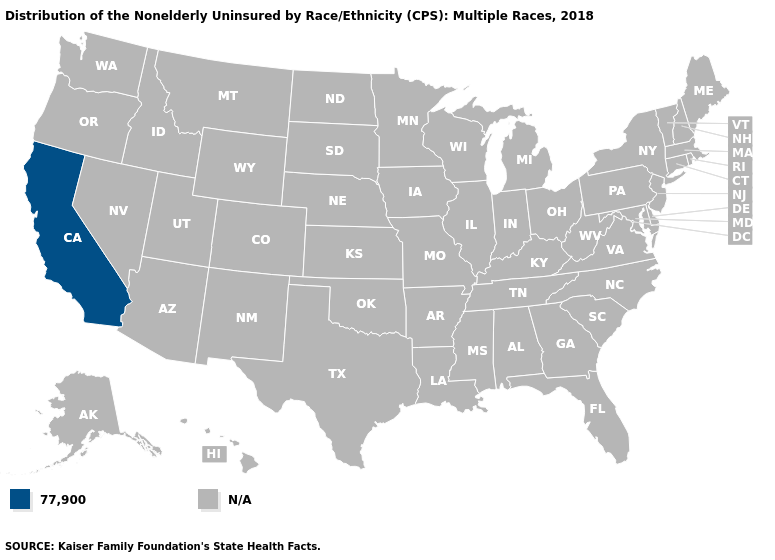What is the highest value in the USA?
Answer briefly. 77,900. Name the states that have a value in the range N/A?
Answer briefly. Alabama, Alaska, Arizona, Arkansas, Colorado, Connecticut, Delaware, Florida, Georgia, Hawaii, Idaho, Illinois, Indiana, Iowa, Kansas, Kentucky, Louisiana, Maine, Maryland, Massachusetts, Michigan, Minnesota, Mississippi, Missouri, Montana, Nebraska, Nevada, New Hampshire, New Jersey, New Mexico, New York, North Carolina, North Dakota, Ohio, Oklahoma, Oregon, Pennsylvania, Rhode Island, South Carolina, South Dakota, Tennessee, Texas, Utah, Vermont, Virginia, Washington, West Virginia, Wisconsin, Wyoming. Does the first symbol in the legend represent the smallest category?
Concise answer only. Yes. Name the states that have a value in the range 77,900?
Write a very short answer. California. Name the states that have a value in the range 77,900?
Short answer required. California. How many symbols are there in the legend?
Quick response, please. 2. Name the states that have a value in the range 77,900?
Answer briefly. California. Name the states that have a value in the range N/A?
Concise answer only. Alabama, Alaska, Arizona, Arkansas, Colorado, Connecticut, Delaware, Florida, Georgia, Hawaii, Idaho, Illinois, Indiana, Iowa, Kansas, Kentucky, Louisiana, Maine, Maryland, Massachusetts, Michigan, Minnesota, Mississippi, Missouri, Montana, Nebraska, Nevada, New Hampshire, New Jersey, New Mexico, New York, North Carolina, North Dakota, Ohio, Oklahoma, Oregon, Pennsylvania, Rhode Island, South Carolina, South Dakota, Tennessee, Texas, Utah, Vermont, Virginia, Washington, West Virginia, Wisconsin, Wyoming. What is the value of Missouri?
Keep it brief. N/A. 